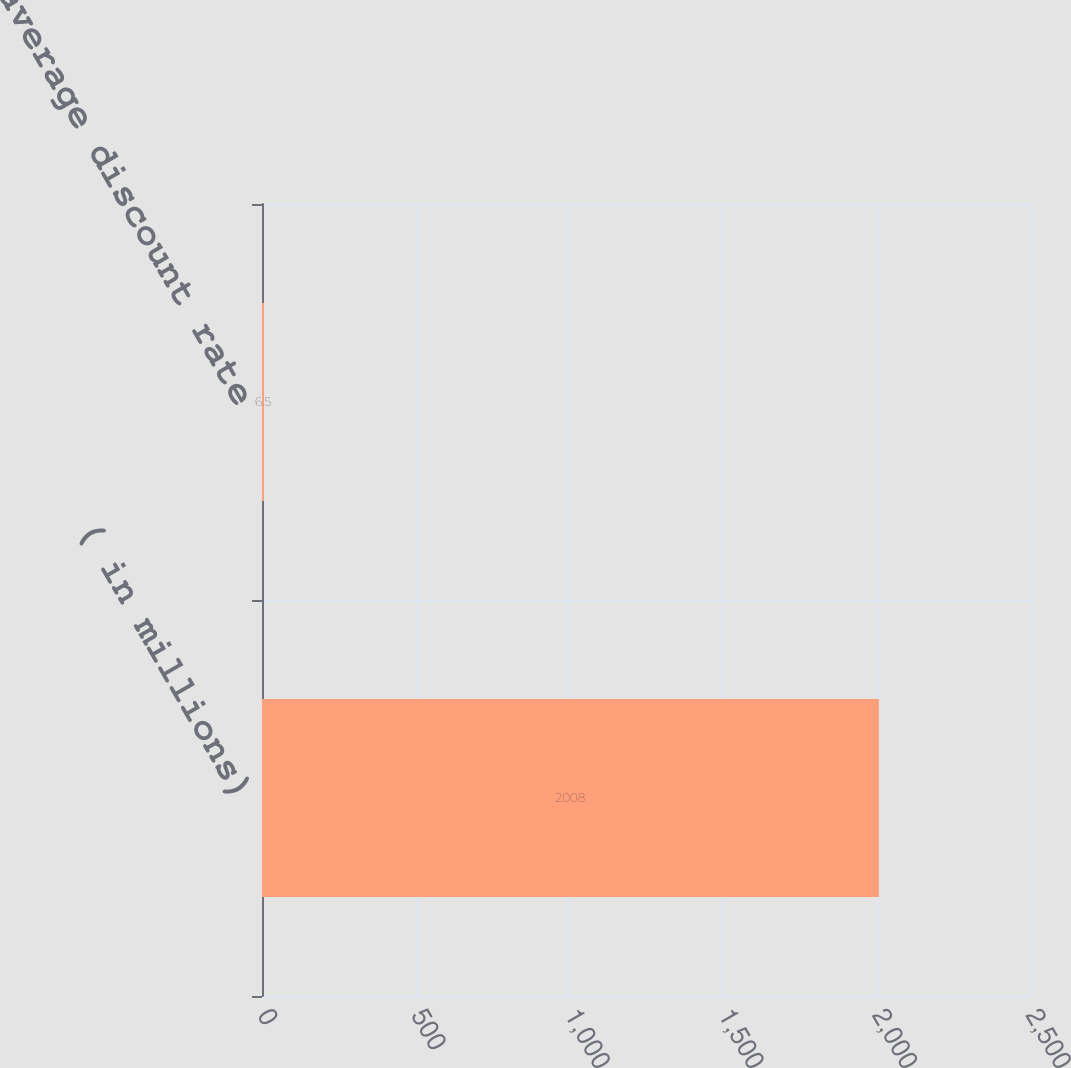Convert chart to OTSL. <chart><loc_0><loc_0><loc_500><loc_500><bar_chart><fcel>( in millions)<fcel>Weighted average discount rate<nl><fcel>2008<fcel>6.5<nl></chart> 